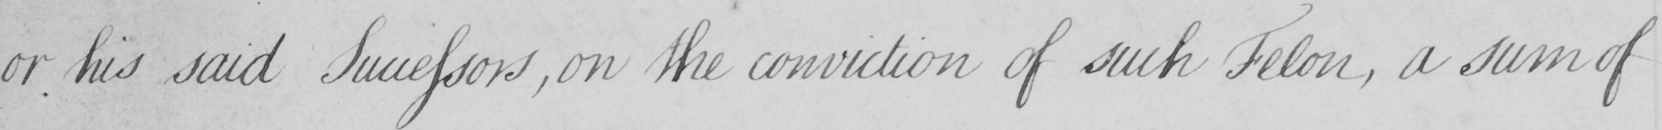Please transcribe the handwritten text in this image. or his said Successors , on the conviction of such Felon , a sum of 